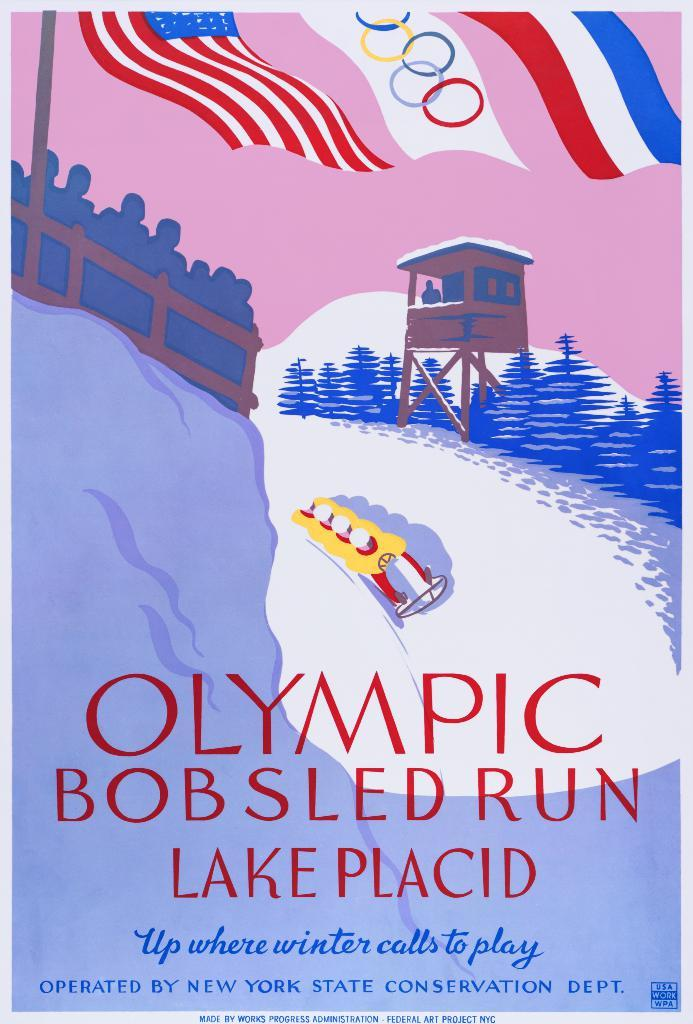What is featured on the poster in the image? The facts do not specify what is on the poster. What else can be seen in the image besides the poster? There are persons, flags, plants, and a pole in the image. How many flags are visible in the image? The facts do not specify the number of flags. What type of plants are present in the image? The facts do not specify the type of plants. What is the degree of quietness in the image? The image does not convey any information about the level of quietness, as it is a visual medium. 